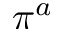Convert formula to latex. <formula><loc_0><loc_0><loc_500><loc_500>\pi ^ { a }</formula> 